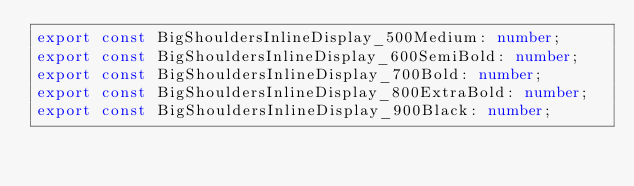<code> <loc_0><loc_0><loc_500><loc_500><_TypeScript_>export const BigShouldersInlineDisplay_500Medium: number;
export const BigShouldersInlineDisplay_600SemiBold: number;
export const BigShouldersInlineDisplay_700Bold: number;
export const BigShouldersInlineDisplay_800ExtraBold: number;
export const BigShouldersInlineDisplay_900Black: number;
</code> 